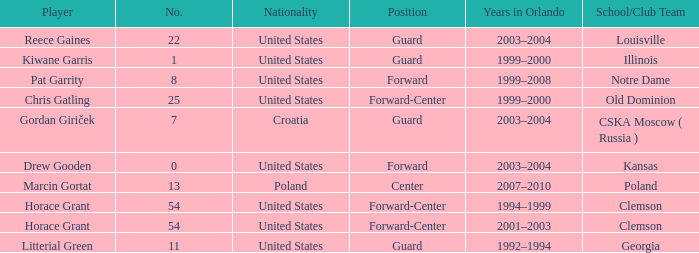What is Chris Gatling 's number? 25.0. 